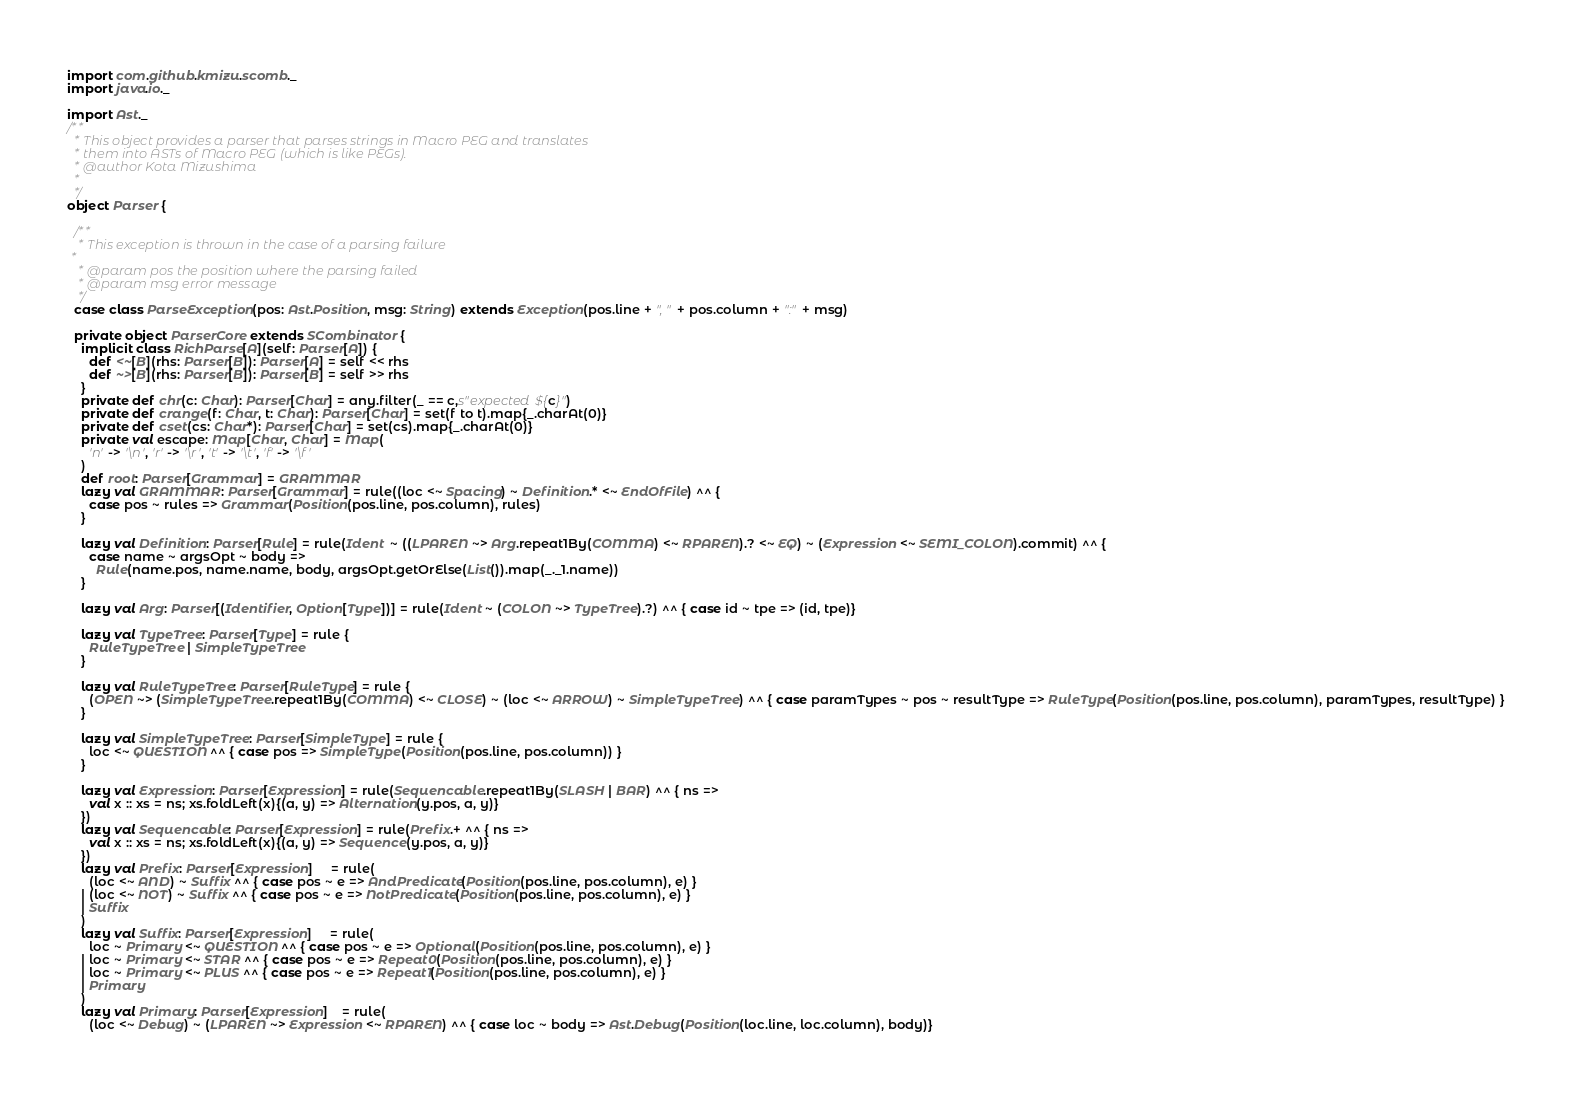Convert code to text. <code><loc_0><loc_0><loc_500><loc_500><_Scala_>
import com.github.kmizu.scomb._
import java.io._

import Ast._
/**
  * This object provides a parser that parses strings in Macro PEG and translates
  * them into ASTs of Macro PEG (which is like PEGs).
  * @author Kota Mizushima
  *
  */
object Parser {

  /**
   * This exception is thrown in the case of a parsing failure
 *
   * @param pos the position where the parsing failed
   * @param msg error message
   */
  case class ParseException(pos: Ast.Position, msg: String) extends Exception(pos.line + ", " + pos.column + ":" + msg)
  
  private object ParserCore extends SCombinator {
    implicit class RichParse[A](self: Parser[A]) {
      def <~[B](rhs: Parser[B]): Parser[A] = self << rhs
      def ~>[B](rhs: Parser[B]): Parser[B] = self >> rhs
    }
    private def chr(c: Char): Parser[Char] = any.filter(_ == c,s"expected ${c}")
    private def crange(f: Char, t: Char): Parser[Char] = set(f to t).map{_.charAt(0)}
    private def cset(cs: Char*): Parser[Char] = set(cs).map{_.charAt(0)}
    private val escape: Map[Char, Char] = Map(
      'n' -> '\n', 'r' -> '\r', 't' -> '\t', 'f' -> '\f'
    )
    def root: Parser[Grammar] = GRAMMAR
    lazy val GRAMMAR: Parser[Grammar] = rule((loc <~ Spacing) ~ Definition.* <~ EndOfFile) ^^ {
      case pos ~ rules => Grammar(Position(pos.line, pos.column), rules)
    }

    lazy val Definition: Parser[Rule] = rule(Ident  ~ ((LPAREN ~> Arg.repeat1By(COMMA) <~ RPAREN).? <~ EQ) ~ (Expression <~ SEMI_COLON).commit) ^^ {
      case name ~ argsOpt ~ body =>
        Rule(name.pos, name.name, body, argsOpt.getOrElse(List()).map(_._1.name))
    }

    lazy val Arg: Parser[(Identifier, Option[Type])] = rule(Ident ~ (COLON ~> TypeTree).?) ^^ { case id ~ tpe => (id, tpe)}

    lazy val TypeTree: Parser[Type] = rule {
      RuleTypeTree | SimpleTypeTree
    }

    lazy val RuleTypeTree: Parser[RuleType] = rule {
      (OPEN ~> (SimpleTypeTree.repeat1By(COMMA) <~ CLOSE) ~ (loc <~ ARROW) ~ SimpleTypeTree) ^^ { case paramTypes ~ pos ~ resultType => RuleType(Position(pos.line, pos.column), paramTypes, resultType) }
    }

    lazy val SimpleTypeTree: Parser[SimpleType] = rule {
      loc <~ QUESTION ^^ { case pos => SimpleType(Position(pos.line, pos.column)) }
    }
    
    lazy val Expression: Parser[Expression] = rule(Sequencable.repeat1By(SLASH | BAR) ^^ { ns =>
      val x :: xs = ns; xs.foldLeft(x){(a, y) => Alternation(y.pos, a, y)}
    })
    lazy val Sequencable: Parser[Expression] = rule(Prefix.+ ^^ { ns =>
      val x :: xs = ns; xs.foldLeft(x){(a, y) => Sequence(y.pos, a, y)}
    })
    lazy val Prefix: Parser[Expression]     = rule(
      (loc <~ AND) ~ Suffix ^^ { case pos ~ e => AndPredicate(Position(pos.line, pos.column), e) }
    | (loc <~ NOT) ~ Suffix ^^ { case pos ~ e => NotPredicate(Position(pos.line, pos.column), e) }
    | Suffix
    )
    lazy val Suffix: Parser[Expression]     = rule(
      loc ~ Primary <~ QUESTION ^^ { case pos ~ e => Optional(Position(pos.line, pos.column), e) }
    | loc ~ Primary <~ STAR ^^ { case pos ~ e => Repeat0(Position(pos.line, pos.column), e) }
    | loc ~ Primary <~ PLUS ^^ { case pos ~ e => Repeat1(Position(pos.line, pos.column), e) }
    | Primary
    )
    lazy val Primary: Parser[Expression]    = rule(
      (loc <~ Debug) ~ (LPAREN ~> Expression <~ RPAREN) ^^ { case loc ~ body => Ast.Debug(Position(loc.line, loc.column), body)}</code> 